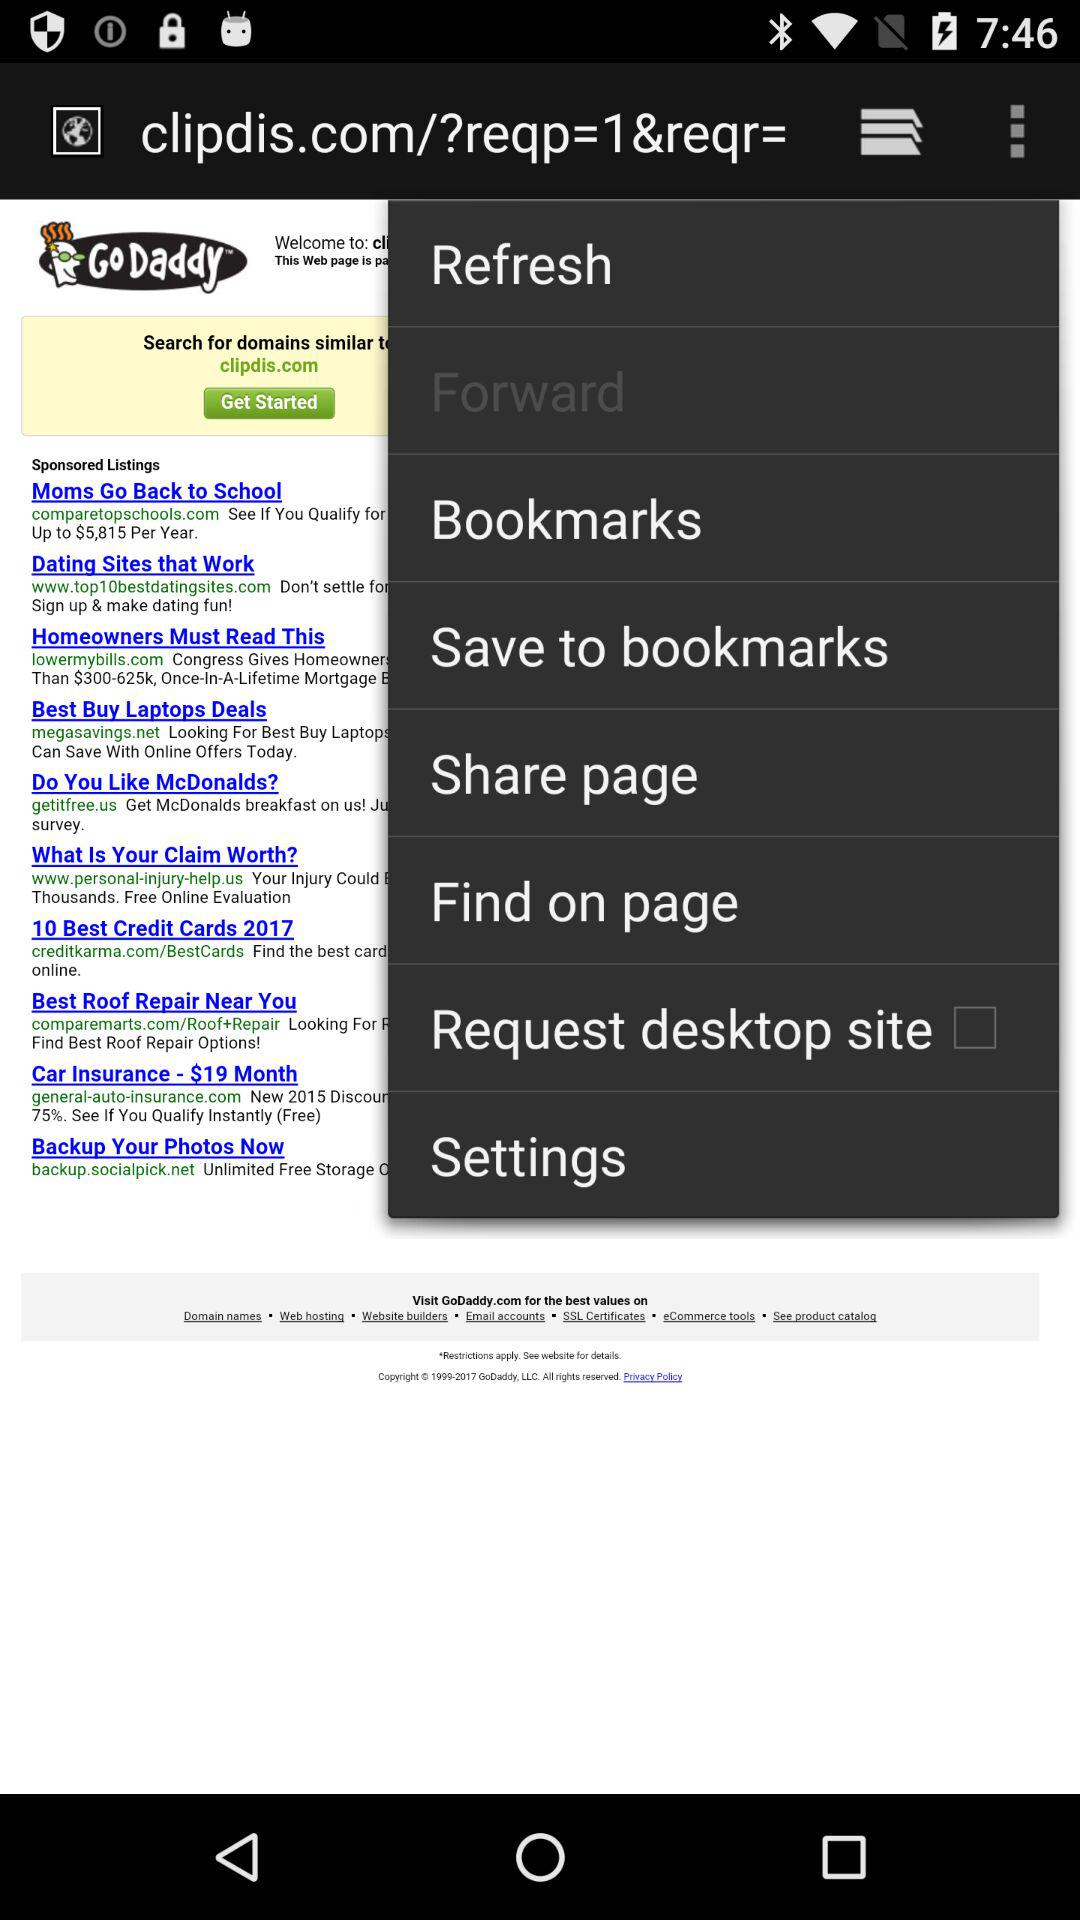What is the selected option?
When the provided information is insufficient, respond with <no answer>. <no answer> 